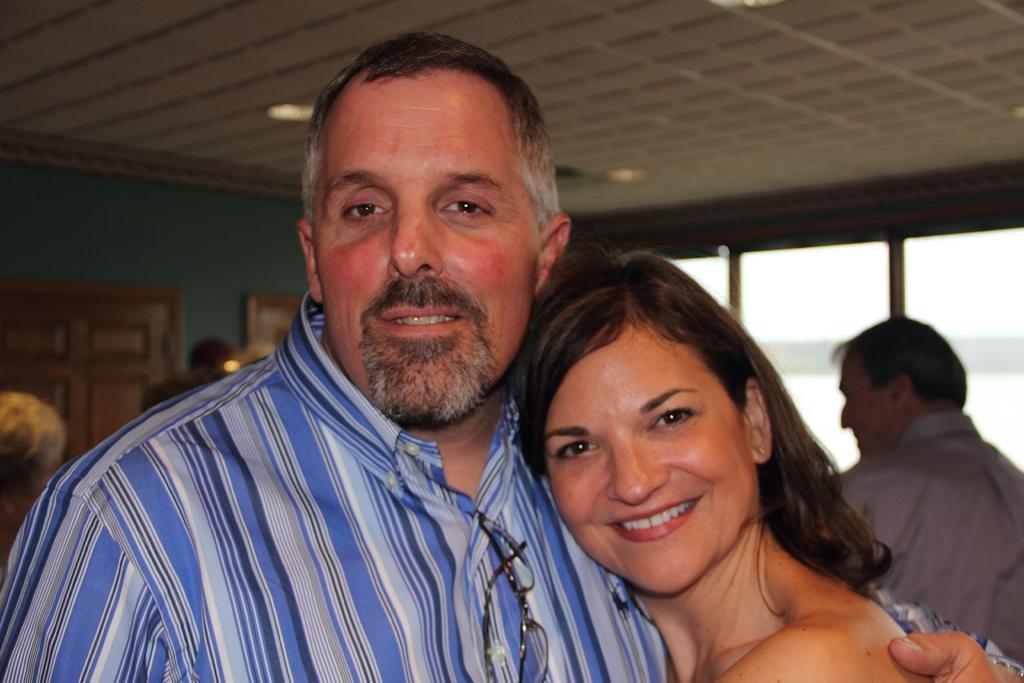How would you summarize this image in a sentence or two? In the picture I can see people are standing on the floor. In the background I can see lights on the ceiling, a wall, windows and some other objects. The background of the image is blurred. 